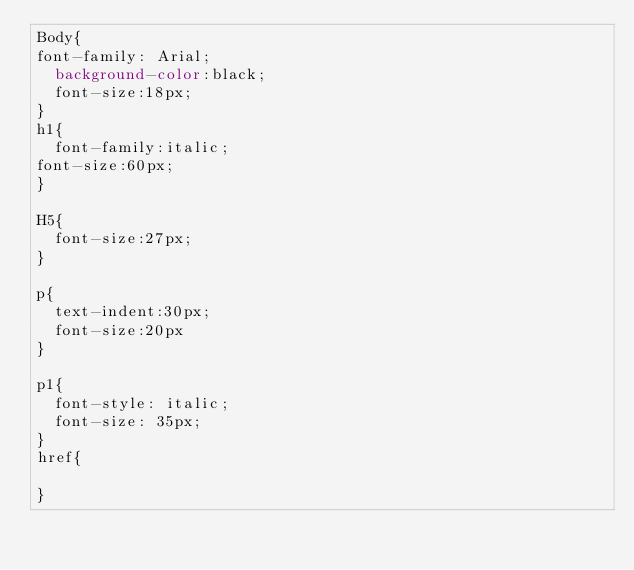Convert code to text. <code><loc_0><loc_0><loc_500><loc_500><_CSS_>Body{
font-family: Arial;
  background-color:black; 
  font-size:18px;
}
h1{
  font-family:italic;
font-size:60px;  
}

H5{
  font-size:27px;
}

p{
  text-indent:30px;
  font-size:20px
}

p1{
  font-style: italic;
  font-size: 35px;  
}
href{
  
}</code> 